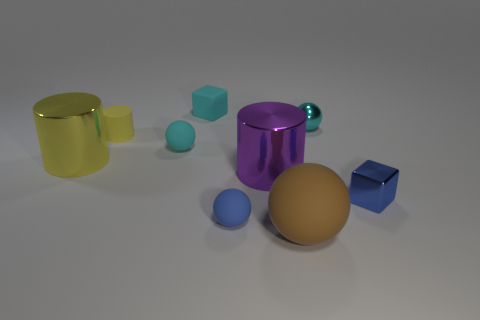Subtract all cyan cylinders. How many cyan balls are left? 2 Subtract all big purple cylinders. How many cylinders are left? 2 Subtract 1 cylinders. How many cylinders are left? 2 Subtract all blue balls. How many balls are left? 3 Subtract all blue balls. Subtract all brown cylinders. How many balls are left? 3 Subtract 0 yellow spheres. How many objects are left? 9 Subtract all balls. How many objects are left? 5 Subtract all small cyan matte balls. Subtract all balls. How many objects are left? 4 Add 5 small rubber blocks. How many small rubber blocks are left? 6 Add 5 small brown shiny cylinders. How many small brown shiny cylinders exist? 5 